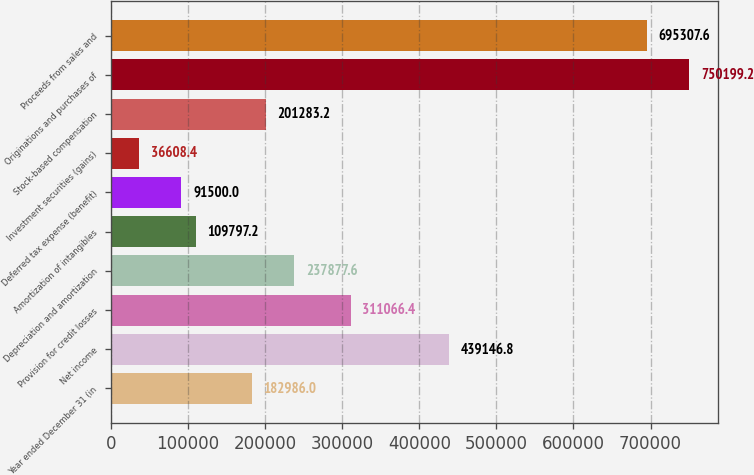<chart> <loc_0><loc_0><loc_500><loc_500><bar_chart><fcel>Year ended December 31 (in<fcel>Net income<fcel>Provision for credit losses<fcel>Depreciation and amortization<fcel>Amortization of intangibles<fcel>Deferred tax expense (benefit)<fcel>Investment securities (gains)<fcel>Stock-based compensation<fcel>Originations and purchases of<fcel>Proceeds from sales and<nl><fcel>182986<fcel>439147<fcel>311066<fcel>237878<fcel>109797<fcel>91500<fcel>36608.4<fcel>201283<fcel>750199<fcel>695308<nl></chart> 